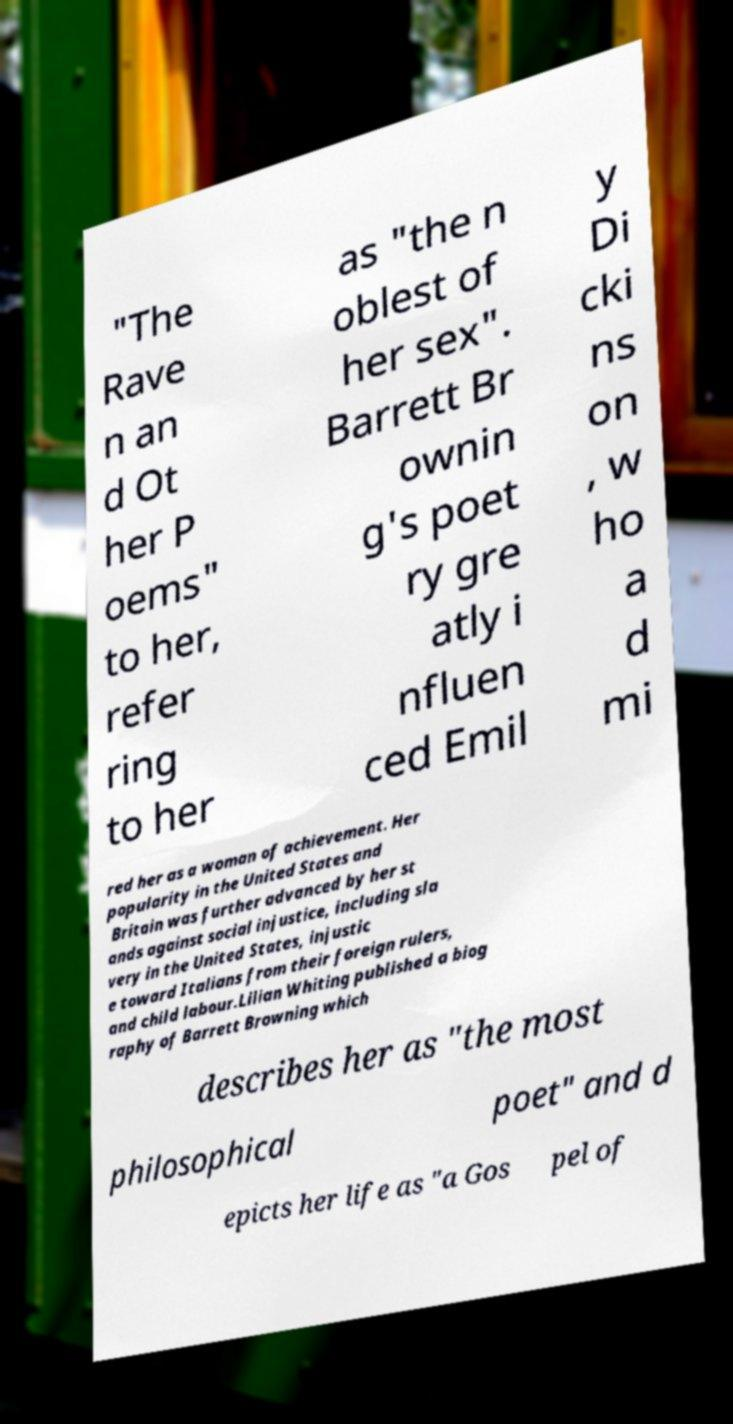For documentation purposes, I need the text within this image transcribed. Could you provide that? "The Rave n an d Ot her P oems" to her, refer ring to her as "the n oblest of her sex". Barrett Br ownin g's poet ry gre atly i nfluen ced Emil y Di cki ns on , w ho a d mi red her as a woman of achievement. Her popularity in the United States and Britain was further advanced by her st ands against social injustice, including sla very in the United States, injustic e toward Italians from their foreign rulers, and child labour.Lilian Whiting published a biog raphy of Barrett Browning which describes her as "the most philosophical poet" and d epicts her life as "a Gos pel of 